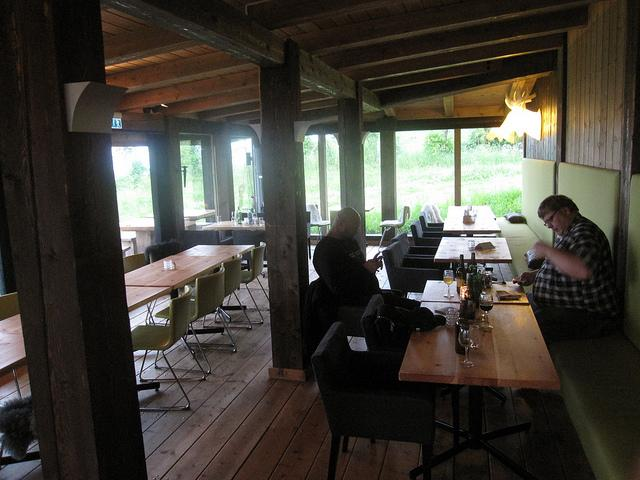What kind of shirt is the heavier man wearing? Please explain your reasoning. checkered. The pattern of the man's shirt is alternating black and white squares. 